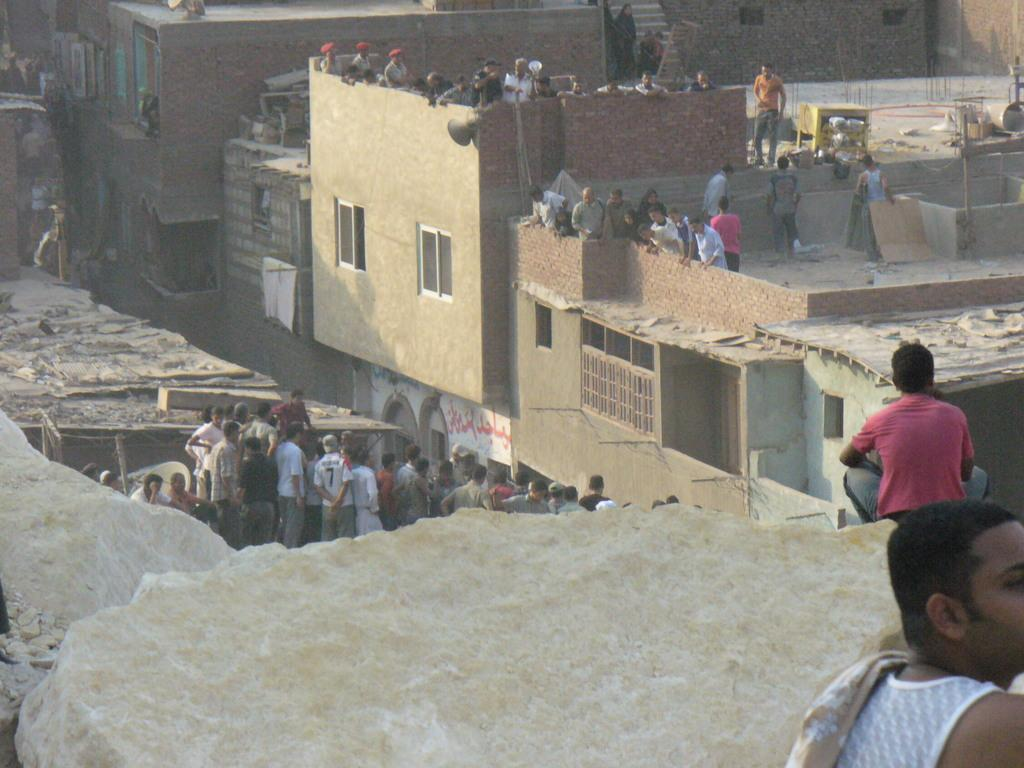Who or what can be seen in the image? There are people in the image. What type of structures are visible in the image? There are buildings in the image. What natural elements can be seen in the image? There are rocks in the image. Can you describe the objects in the top right corner of the image? There is a table in the top right corner of the image. What other man-made objects are present in the image? There are poles and iron rods in the image. What type of pies are being transported by the rat in the image? There is no rat or pies present in the image. How does the rat use the iron rods for transport in the image? There is no rat or iron rods being used for transport in the image. 